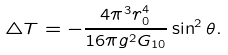Convert formula to latex. <formula><loc_0><loc_0><loc_500><loc_500>\triangle T = - \frac { 4 \pi ^ { 3 } r _ { 0 } ^ { 4 } } { 1 6 \pi g ^ { 2 } G _ { 1 0 } } \sin ^ { 2 } \theta .</formula> 